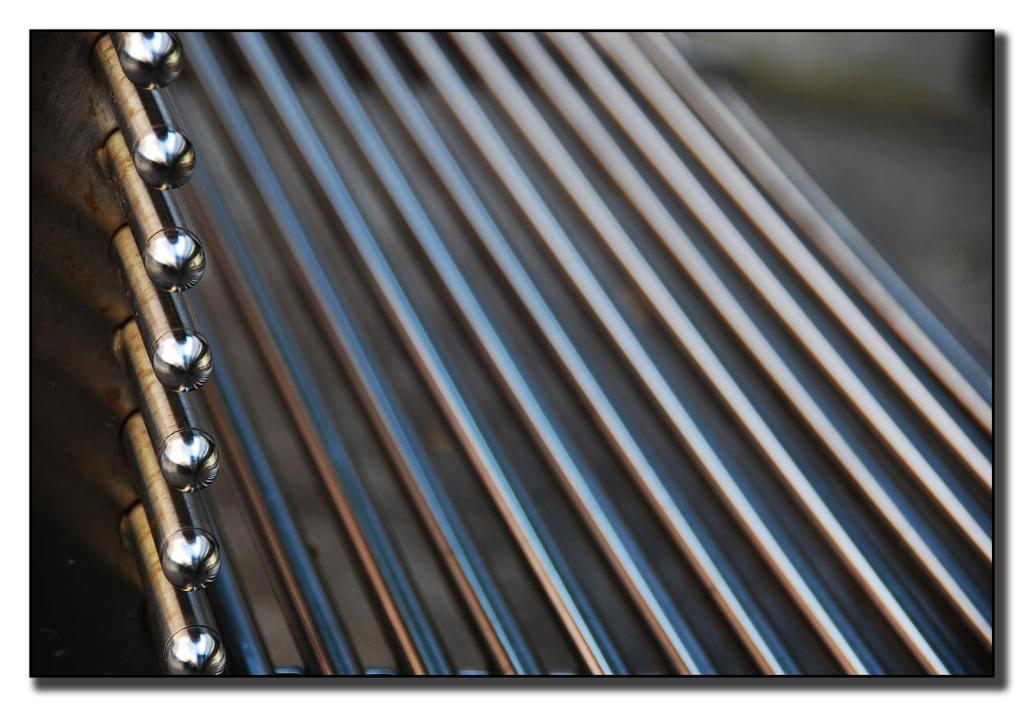What material is the sheet in the image made of? The sheet in the image is made of metal. What other metal objects can be seen in the image? There are metal rods in the image. How many visitors can be seen in the image? There are no visitors present in the image; it only features a metal sheet and metal rods. What type of prose is being written on the metal sheet in the image? There is no prose present on the metal sheet in the image; it is a plain metal sheet. 